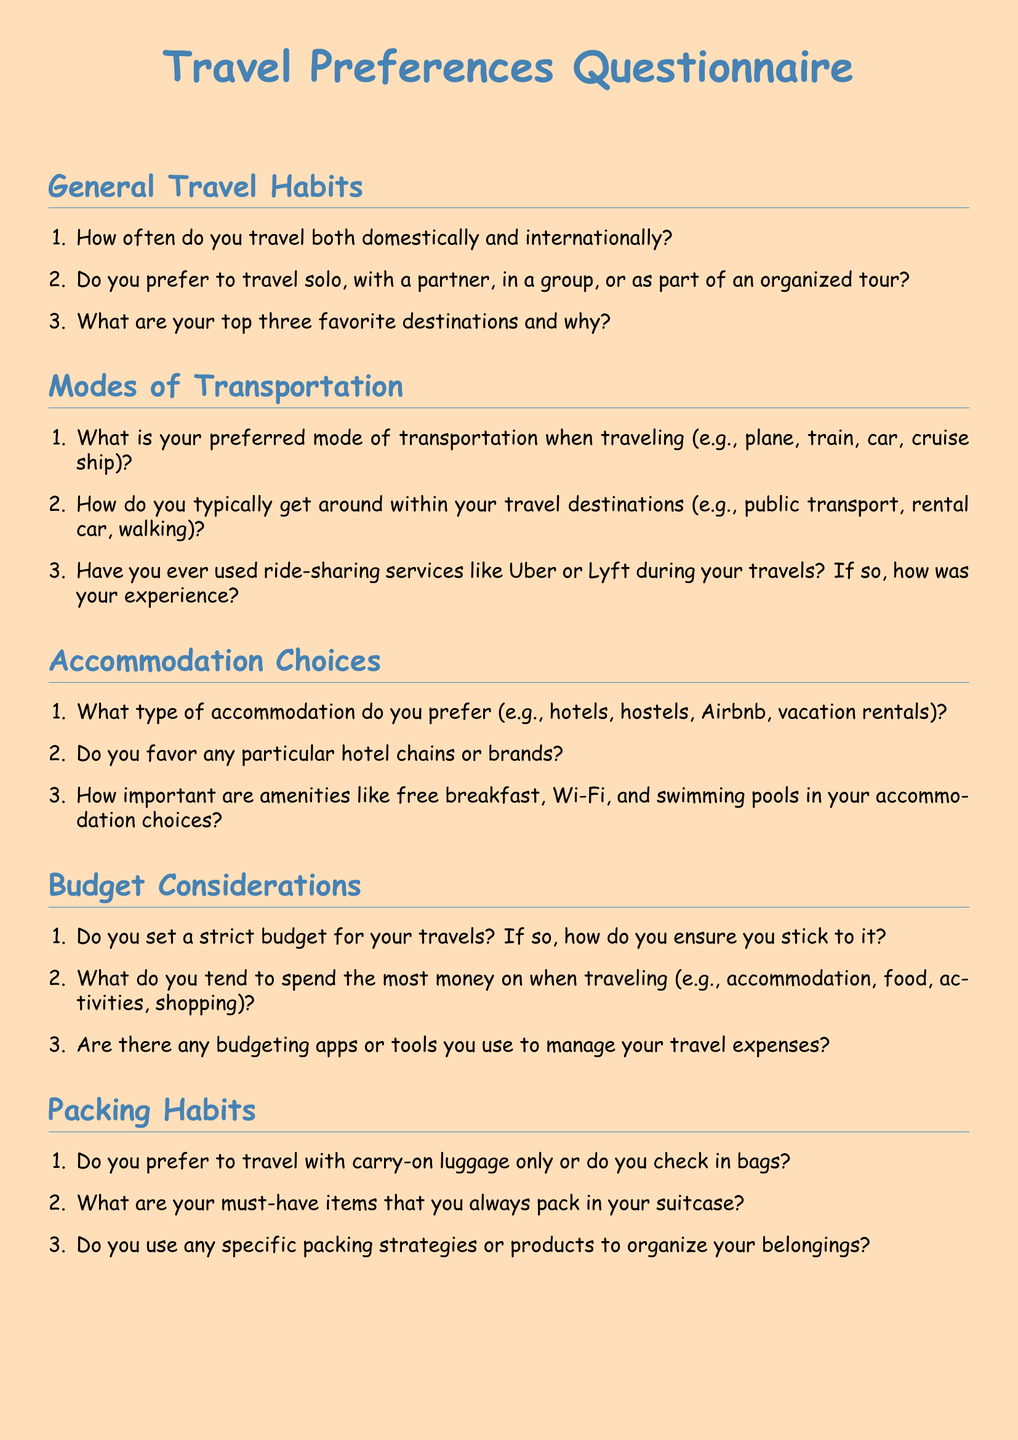What is the title of the document? The title of the document is presented prominently at the top, stating the purpose of the document.
Answer: Travel Preferences Questionnaire How many sections are there in the document? The document is divided into five main sections, each covering a different aspect of travel preferences.
Answer: 5 What is the first question under General Travel Habits? The first question in the General Travel Habits section inquires about the frequency of travel.
Answer: How often do you travel both domestically and internationally? What type of accommodation does the document mention? The document lists specific types of accommodation preferences in the corresponding section.
Answer: hotels, hostels, Airbnb, vacation rentals What is a key consideration for accommodation choices according to the document? The document specifies amenities that influence accommodation choices, highlighting their importance.
Answer: free breakfast, Wi-Fi, swimming pools What is suggested as a preferred mode of transportation? The document asks about specific modes of transportation individuals may prefer while traveling.
Answer: plane, train, car, cruise ship What is asked regarding budget considerations? The document addresses the establishment and management of travel budgets within its questions.
Answer: set a strict budget What is one must-have item to pack according to the document? The document refers to essential items travelers should consistently include in their luggage.
Answer: must-have items What does the document suggest about ride-sharing services? The document prompts for personal experiences regarding the use of ride-sharing during travels.
Answer: experience with Uber or Lyft 